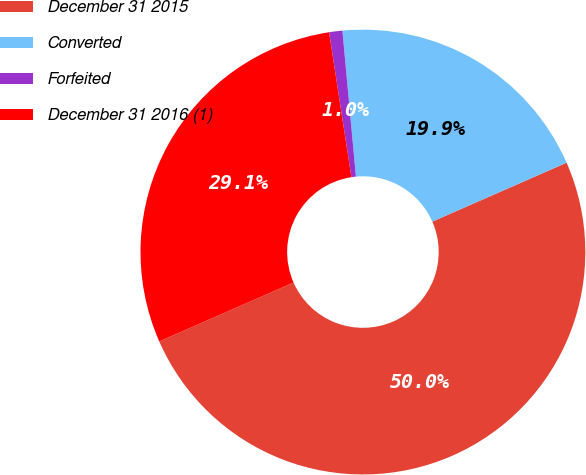Convert chart. <chart><loc_0><loc_0><loc_500><loc_500><pie_chart><fcel>December 31 2015<fcel>Converted<fcel>Forfeited<fcel>December 31 2016 (1)<nl><fcel>50.0%<fcel>19.89%<fcel>0.96%<fcel>29.15%<nl></chart> 